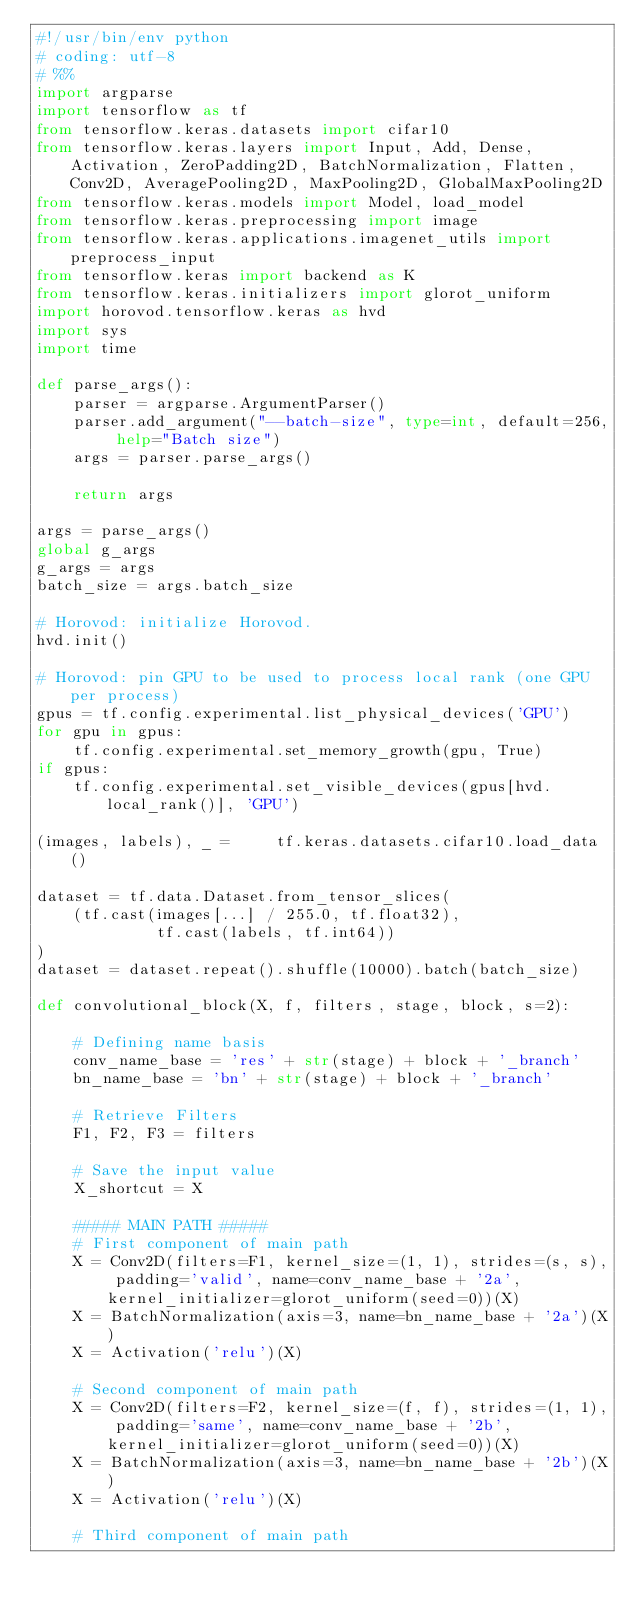Convert code to text. <code><loc_0><loc_0><loc_500><loc_500><_Python_>#!/usr/bin/env python
# coding: utf-8
# %%
import argparse
import tensorflow as tf
from tensorflow.keras.datasets import cifar10
from tensorflow.keras.layers import Input, Add, Dense, Activation, ZeroPadding2D, BatchNormalization, Flatten, Conv2D, AveragePooling2D, MaxPooling2D, GlobalMaxPooling2D
from tensorflow.keras.models import Model, load_model
from tensorflow.keras.preprocessing import image
from tensorflow.keras.applications.imagenet_utils import preprocess_input
from tensorflow.keras import backend as K
from tensorflow.keras.initializers import glorot_uniform
import horovod.tensorflow.keras as hvd
import sys
import time

def parse_args():
    parser = argparse.ArgumentParser()
    parser.add_argument("--batch-size", type=int, default=256, help="Batch size")
    args = parser.parse_args()

    return args

args = parse_args()
global g_args
g_args = args
batch_size = args.batch_size

# Horovod: initialize Horovod.
hvd.init()

# Horovod: pin GPU to be used to process local rank (one GPU per process)
gpus = tf.config.experimental.list_physical_devices('GPU')
for gpu in gpus:
    tf.config.experimental.set_memory_growth(gpu, True)
if gpus:
    tf.config.experimental.set_visible_devices(gpus[hvd.local_rank()], 'GPU')

(images, labels), _ =     tf.keras.datasets.cifar10.load_data()

dataset = tf.data.Dataset.from_tensor_slices(
    (tf.cast(images[...] / 255.0, tf.float32),
             tf.cast(labels, tf.int64))
)
dataset = dataset.repeat().shuffle(10000).batch(batch_size)

def convolutional_block(X, f, filters, stage, block, s=2):

    # Defining name basis
    conv_name_base = 'res' + str(stage) + block + '_branch'
    bn_name_base = 'bn' + str(stage) + block + '_branch'

    # Retrieve Filters
    F1, F2, F3 = filters

    # Save the input value
    X_shortcut = X

    ##### MAIN PATH #####
    # First component of main path 
    X = Conv2D(filters=F1, kernel_size=(1, 1), strides=(s, s), padding='valid', name=conv_name_base + '2a', kernel_initializer=glorot_uniform(seed=0))(X)
    X = BatchNormalization(axis=3, name=bn_name_base + '2a')(X)
    X = Activation('relu')(X)

    # Second component of main path
    X = Conv2D(filters=F2, kernel_size=(f, f), strides=(1, 1), padding='same', name=conv_name_base + '2b', kernel_initializer=glorot_uniform(seed=0))(X)
    X = BatchNormalization(axis=3, name=bn_name_base + '2b')(X)
    X = Activation('relu')(X)

    # Third component of main path</code> 